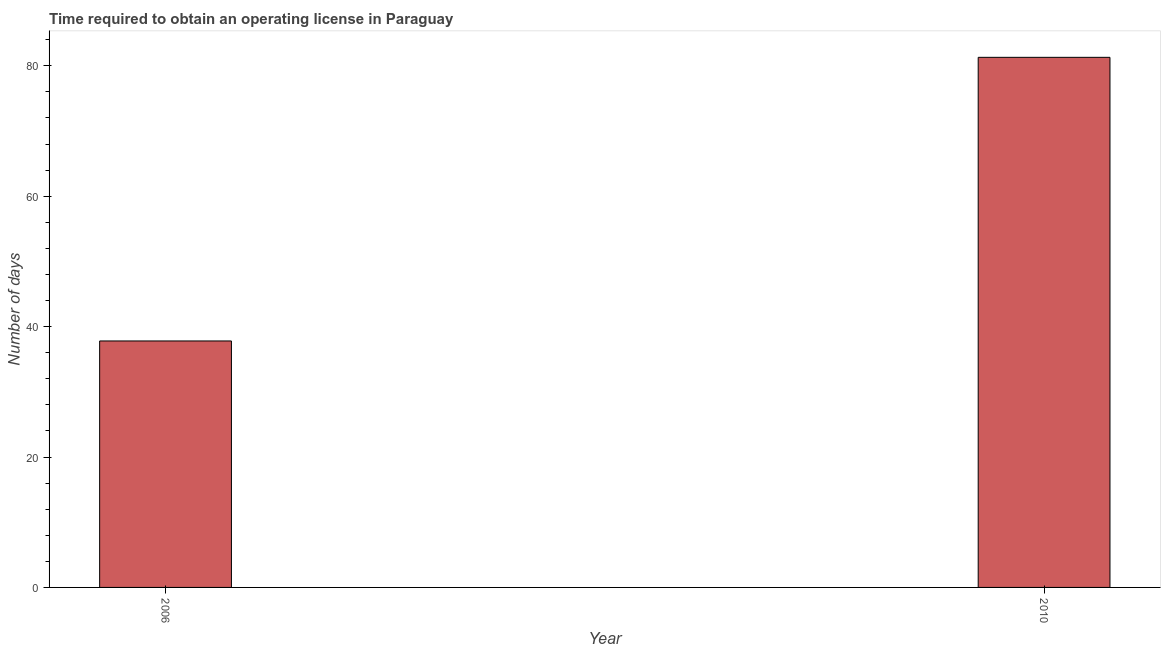What is the title of the graph?
Offer a very short reply. Time required to obtain an operating license in Paraguay. What is the label or title of the X-axis?
Your response must be concise. Year. What is the label or title of the Y-axis?
Your answer should be compact. Number of days. What is the number of days to obtain operating license in 2010?
Offer a terse response. 81.3. Across all years, what is the maximum number of days to obtain operating license?
Your answer should be compact. 81.3. Across all years, what is the minimum number of days to obtain operating license?
Provide a succinct answer. 37.8. What is the sum of the number of days to obtain operating license?
Give a very brief answer. 119.1. What is the difference between the number of days to obtain operating license in 2006 and 2010?
Offer a terse response. -43.5. What is the average number of days to obtain operating license per year?
Keep it short and to the point. 59.55. What is the median number of days to obtain operating license?
Provide a short and direct response. 59.55. Do a majority of the years between 2006 and 2010 (inclusive) have number of days to obtain operating license greater than 48 days?
Keep it short and to the point. No. What is the ratio of the number of days to obtain operating license in 2006 to that in 2010?
Your response must be concise. 0.47. How many bars are there?
Offer a terse response. 2. What is the difference between two consecutive major ticks on the Y-axis?
Make the answer very short. 20. What is the Number of days in 2006?
Your answer should be compact. 37.8. What is the Number of days of 2010?
Offer a very short reply. 81.3. What is the difference between the Number of days in 2006 and 2010?
Your response must be concise. -43.5. What is the ratio of the Number of days in 2006 to that in 2010?
Ensure brevity in your answer.  0.47. 